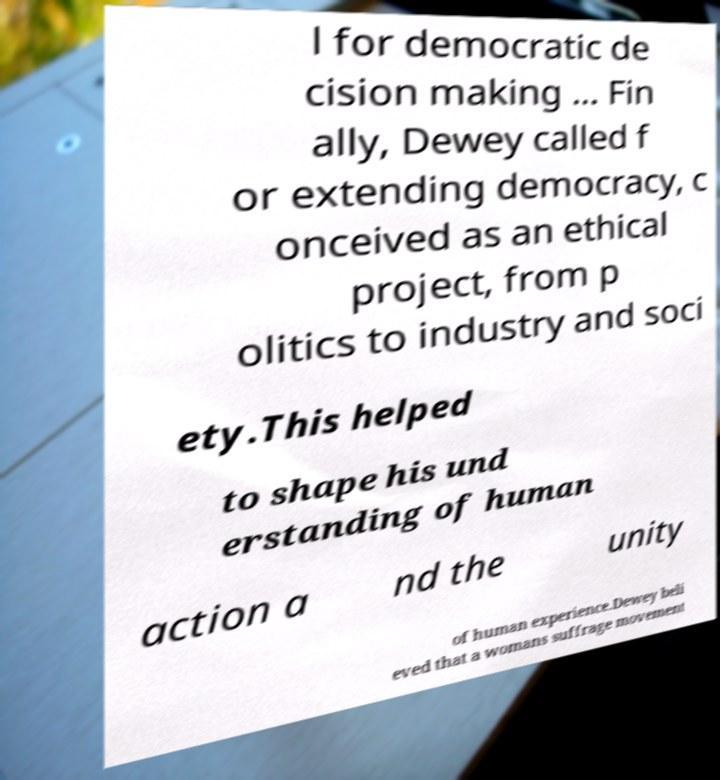Could you extract and type out the text from this image? l for democratic de cision making ... Fin ally, Dewey called f or extending democracy, c onceived as an ethical project, from p olitics to industry and soci ety.This helped to shape his und erstanding of human action a nd the unity of human experience.Dewey beli eved that a womans suffrage movement 